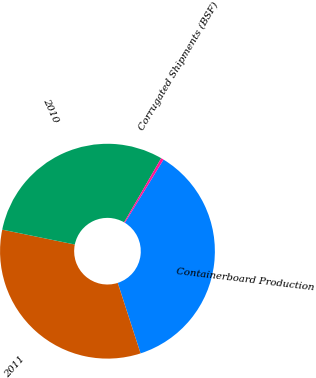<chart> <loc_0><loc_0><loc_500><loc_500><pie_chart><fcel>Containerboard Production<fcel>2011<fcel>2010<fcel>Corrugated Shipments (BSF)<nl><fcel>36.28%<fcel>33.2%<fcel>30.12%<fcel>0.4%<nl></chart> 